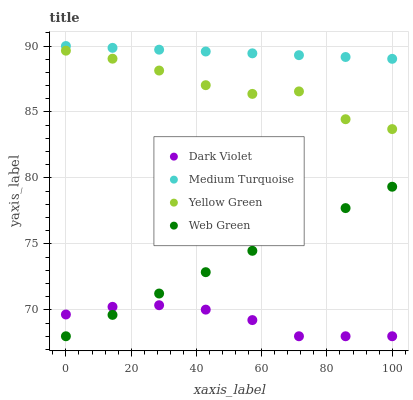Does Dark Violet have the minimum area under the curve?
Answer yes or no. Yes. Does Medium Turquoise have the maximum area under the curve?
Answer yes or no. Yes. Does Medium Turquoise have the minimum area under the curve?
Answer yes or no. No. Does Dark Violet have the maximum area under the curve?
Answer yes or no. No. Is Web Green the smoothest?
Answer yes or no. Yes. Is Yellow Green the roughest?
Answer yes or no. Yes. Is Medium Turquoise the smoothest?
Answer yes or no. No. Is Medium Turquoise the roughest?
Answer yes or no. No. Does Web Green have the lowest value?
Answer yes or no. Yes. Does Medium Turquoise have the lowest value?
Answer yes or no. No. Does Medium Turquoise have the highest value?
Answer yes or no. Yes. Does Dark Violet have the highest value?
Answer yes or no. No. Is Yellow Green less than Medium Turquoise?
Answer yes or no. Yes. Is Medium Turquoise greater than Yellow Green?
Answer yes or no. Yes. Does Dark Violet intersect Web Green?
Answer yes or no. Yes. Is Dark Violet less than Web Green?
Answer yes or no. No. Is Dark Violet greater than Web Green?
Answer yes or no. No. Does Yellow Green intersect Medium Turquoise?
Answer yes or no. No. 